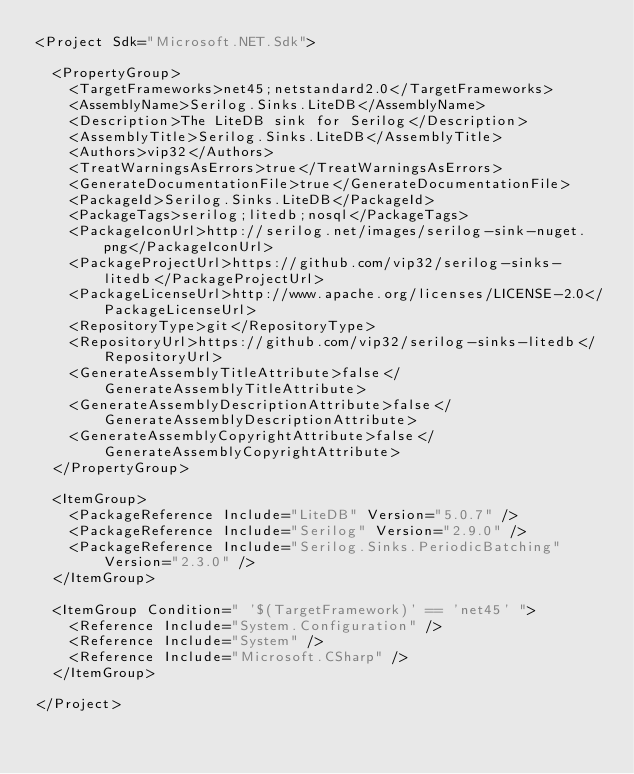Convert code to text. <code><loc_0><loc_0><loc_500><loc_500><_XML_><Project Sdk="Microsoft.NET.Sdk">

  <PropertyGroup>
    <TargetFrameworks>net45;netstandard2.0</TargetFrameworks>
    <AssemblyName>Serilog.Sinks.LiteDB</AssemblyName>
    <Description>The LiteDB sink for Serilog</Description>
    <AssemblyTitle>Serilog.Sinks.LiteDB</AssemblyTitle>
    <Authors>vip32</Authors>
    <TreatWarningsAsErrors>true</TreatWarningsAsErrors>
    <GenerateDocumentationFile>true</GenerateDocumentationFile>
    <PackageId>Serilog.Sinks.LiteDB</PackageId>
    <PackageTags>serilog;litedb;nosql</PackageTags>
    <PackageIconUrl>http://serilog.net/images/serilog-sink-nuget.png</PackageIconUrl>
    <PackageProjectUrl>https://github.com/vip32/serilog-sinks-litedb</PackageProjectUrl>
    <PackageLicenseUrl>http://www.apache.org/licenses/LICENSE-2.0</PackageLicenseUrl>
    <RepositoryType>git</RepositoryType>
    <RepositoryUrl>https://github.com/vip32/serilog-sinks-litedb</RepositoryUrl>
    <GenerateAssemblyTitleAttribute>false</GenerateAssemblyTitleAttribute>
    <GenerateAssemblyDescriptionAttribute>false</GenerateAssemblyDescriptionAttribute>
    <GenerateAssemblyCopyrightAttribute>false</GenerateAssemblyCopyrightAttribute>
  </PropertyGroup>

  <ItemGroup>
    <PackageReference Include="LiteDB" Version="5.0.7" />
    <PackageReference Include="Serilog" Version="2.9.0" />
    <PackageReference Include="Serilog.Sinks.PeriodicBatching" Version="2.3.0" />
  </ItemGroup>

  <ItemGroup Condition=" '$(TargetFramework)' == 'net45' ">
    <Reference Include="System.Configuration" />
    <Reference Include="System" />
    <Reference Include="Microsoft.CSharp" />
  </ItemGroup>

</Project>
</code> 